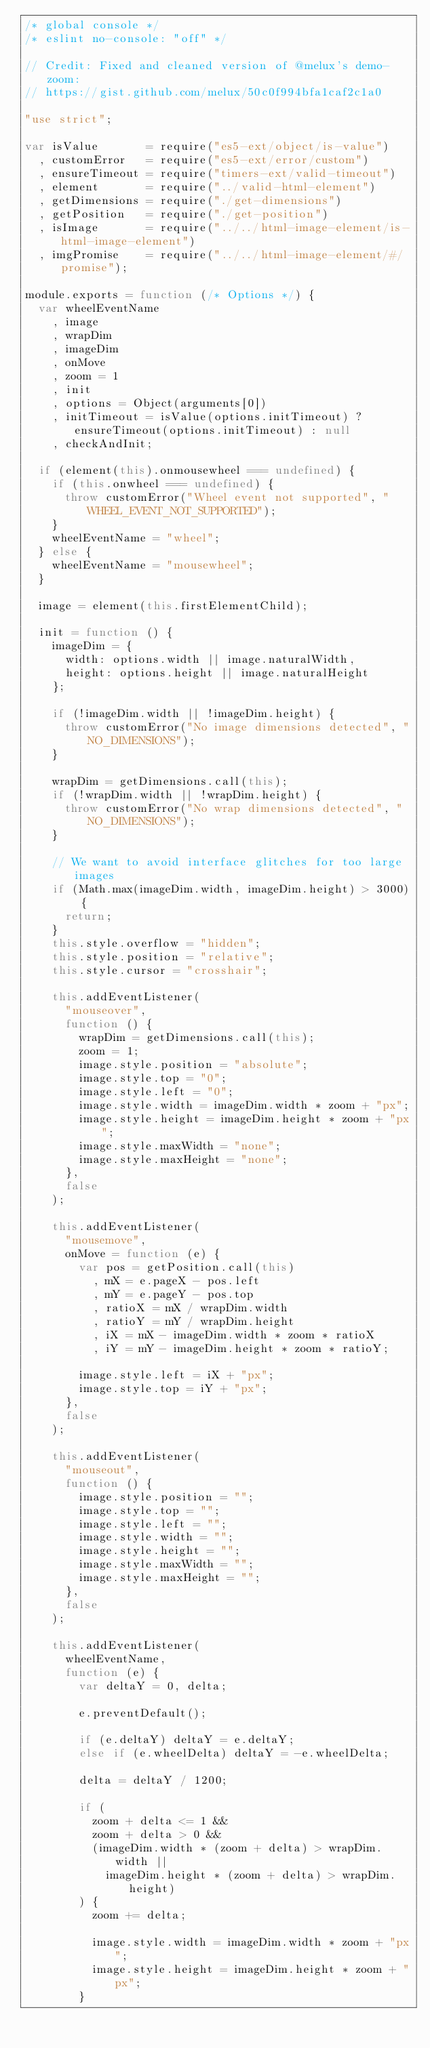Convert code to text. <code><loc_0><loc_0><loc_500><loc_500><_JavaScript_>/* global console */
/* eslint no-console: "off" */

// Credit: Fixed and cleaned version of @melux's demo-zoom:
// https://gist.github.com/melux/50c0f994bfa1caf2c1a0

"use strict";

var isValue       = require("es5-ext/object/is-value")
  , customError   = require("es5-ext/error/custom")
  , ensureTimeout = require("timers-ext/valid-timeout")
  , element       = require("../valid-html-element")
  , getDimensions = require("./get-dimensions")
  , getPosition   = require("./get-position")
  , isImage       = require("../../html-image-element/is-html-image-element")
  , imgPromise    = require("../../html-image-element/#/promise");

module.exports = function (/* Options */) {
	var wheelEventName
	  , image
	  , wrapDim
	  , imageDim
	  , onMove
	  , zoom = 1
	  , init
	  , options = Object(arguments[0])
	  , initTimeout = isValue(options.initTimeout) ? ensureTimeout(options.initTimeout) : null
	  , checkAndInit;

	if (element(this).onmousewheel === undefined) {
		if (this.onwheel === undefined) {
			throw customError("Wheel event not supported", "WHEEL_EVENT_NOT_SUPPORTED");
		}
		wheelEventName = "wheel";
	} else {
		wheelEventName = "mousewheel";
	}

	image = element(this.firstElementChild);

	init = function () {
		imageDim = {
			width: options.width || image.naturalWidth,
			height: options.height || image.naturalHeight
		};

		if (!imageDim.width || !imageDim.height) {
			throw customError("No image dimensions detected", "NO_DIMENSIONS");
		}

		wrapDim = getDimensions.call(this);
		if (!wrapDim.width || !wrapDim.height) {
			throw customError("No wrap dimensions detected", "NO_DIMENSIONS");
		}

		// We want to avoid interface glitches for too large images
		if (Math.max(imageDim.width, imageDim.height) > 3000) {
			return;
		}
		this.style.overflow = "hidden";
		this.style.position = "relative";
		this.style.cursor = "crosshair";

		this.addEventListener(
			"mouseover",
			function () {
				wrapDim = getDimensions.call(this);
				zoom = 1;
				image.style.position = "absolute";
				image.style.top = "0";
				image.style.left = "0";
				image.style.width = imageDim.width * zoom + "px";
				image.style.height = imageDim.height * zoom + "px";
				image.style.maxWidth = "none";
				image.style.maxHeight = "none";
			},
			false
		);

		this.addEventListener(
			"mousemove",
			onMove = function (e) {
				var pos = getPosition.call(this)
				  , mX = e.pageX - pos.left
				  , mY = e.pageY - pos.top
				  , ratioX = mX / wrapDim.width
				  , ratioY = mY / wrapDim.height
				  , iX = mX - imageDim.width * zoom * ratioX
				  , iY = mY - imageDim.height * zoom * ratioY;

				image.style.left = iX + "px";
				image.style.top = iY + "px";
			},
			false
		);

		this.addEventListener(
			"mouseout",
			function () {
				image.style.position = "";
				image.style.top = "";
				image.style.left = "";
				image.style.width = "";
				image.style.height = "";
				image.style.maxWidth = "";
				image.style.maxHeight = "";
			},
			false
		);

		this.addEventListener(
			wheelEventName,
			function (e) {
				var deltaY = 0, delta;

				e.preventDefault();

				if (e.deltaY) deltaY = e.deltaY;
				else if (e.wheelDelta) deltaY = -e.wheelDelta;

				delta = deltaY / 1200;

				if (
					zoom + delta <= 1 &&
					zoom + delta > 0 &&
					(imageDim.width * (zoom + delta) > wrapDim.width ||
						imageDim.height * (zoom + delta) > wrapDim.height)
				) {
					zoom += delta;

					image.style.width = imageDim.width * zoom + "px";
					image.style.height = imageDim.height * zoom + "px";
				}
</code> 